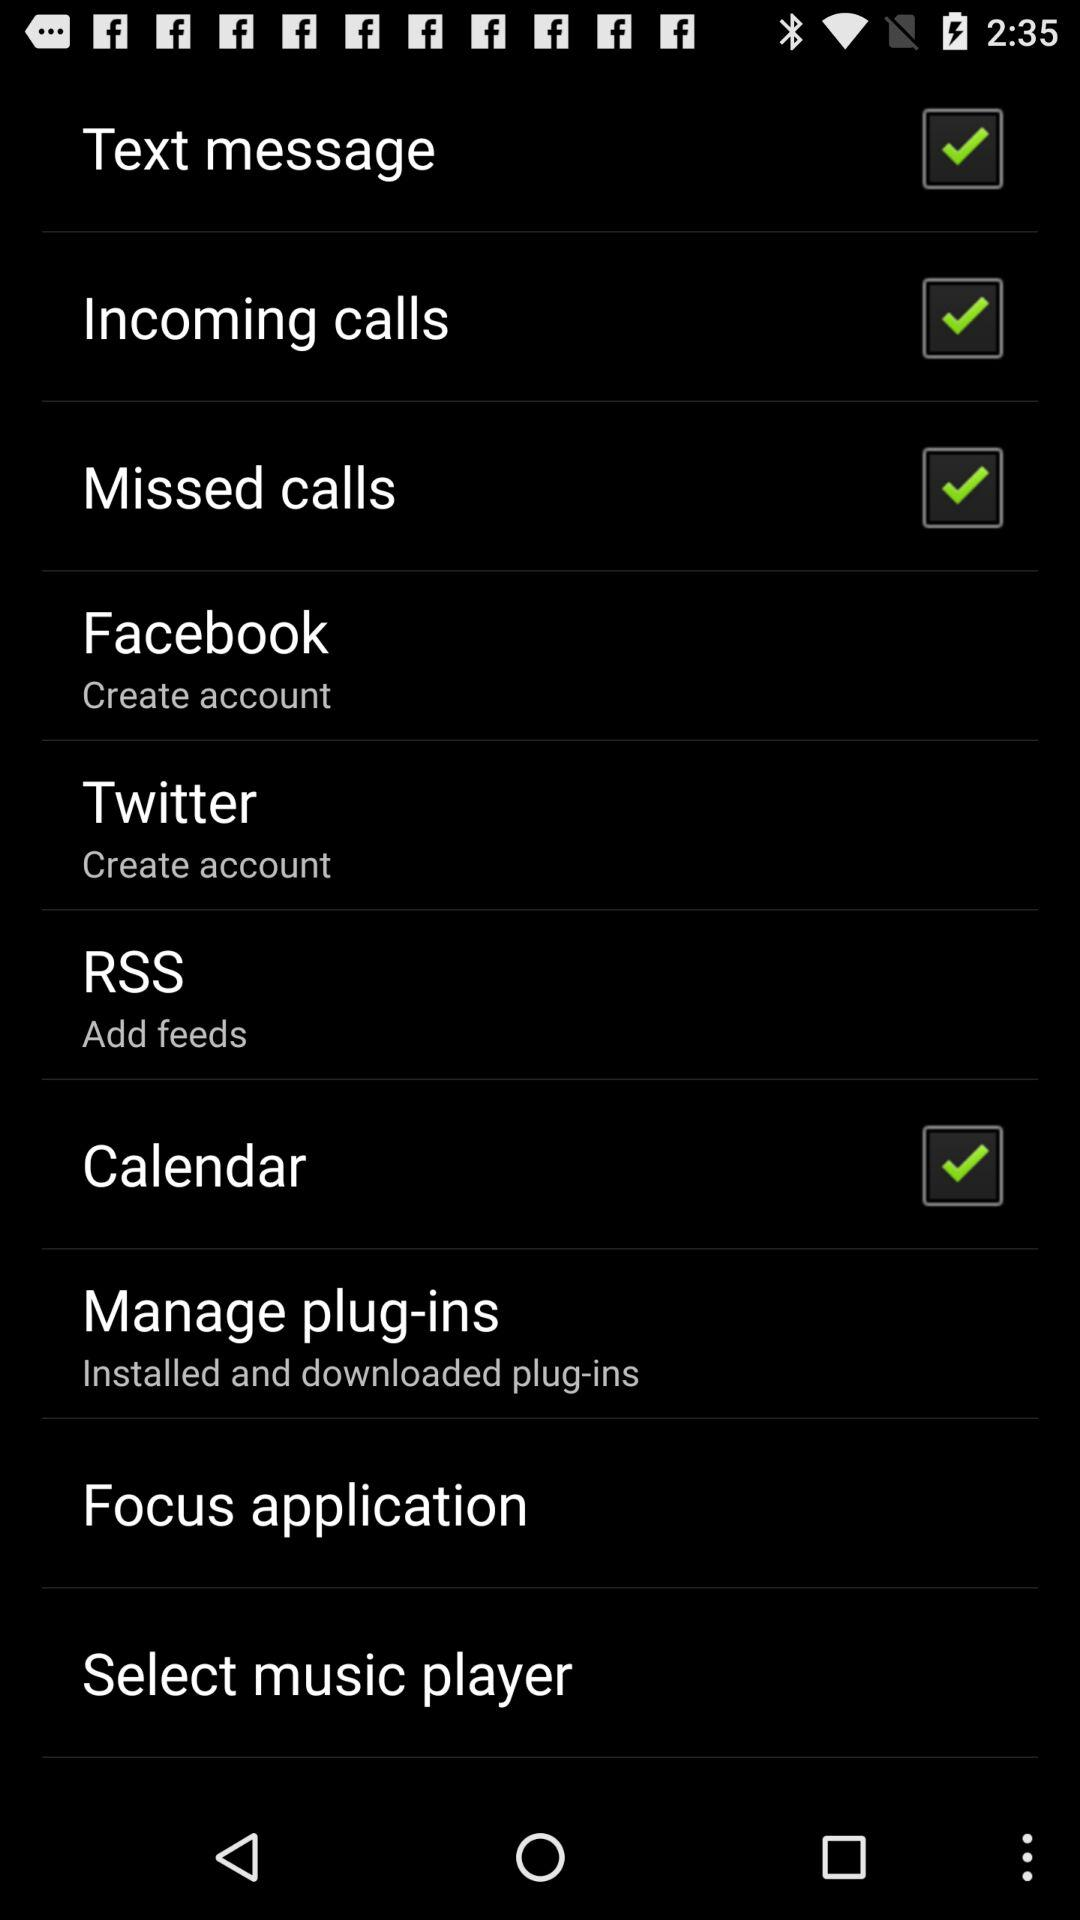What is the status of "Incoming calls"? The status is "on". 